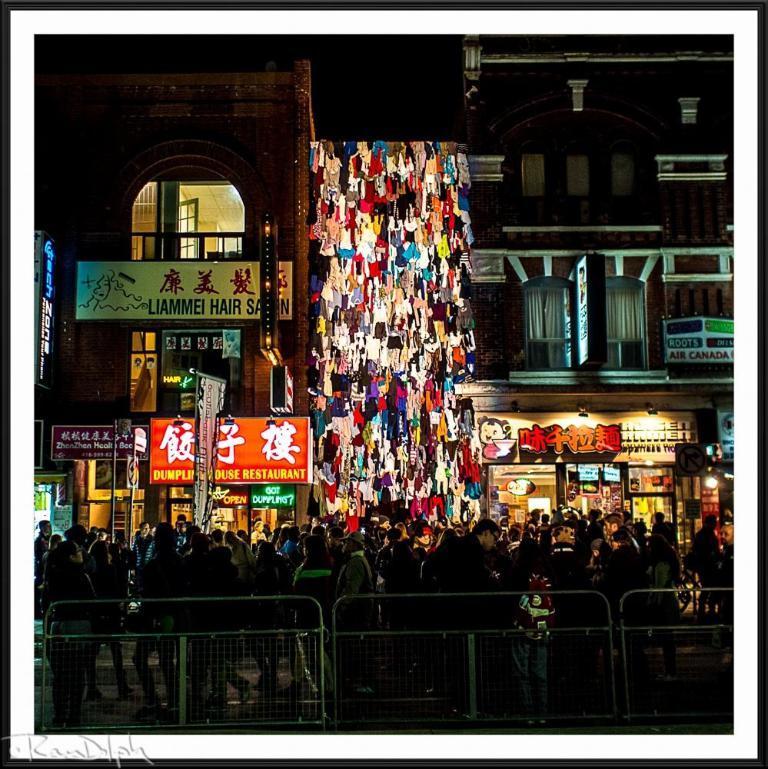In one or two sentences, can you explain what this image depicts? There is a fence and a crowd at the bottom of this image. We can see the buildings in the background. 